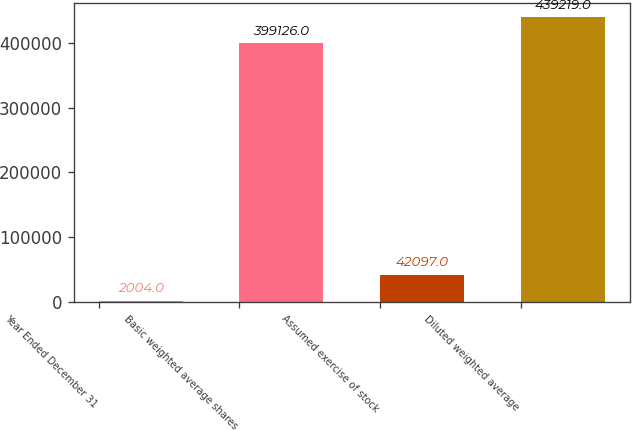Convert chart. <chart><loc_0><loc_0><loc_500><loc_500><bar_chart><fcel>Year Ended December 31<fcel>Basic weighted average shares<fcel>Assumed exercise of stock<fcel>Diluted weighted average<nl><fcel>2004<fcel>399126<fcel>42097<fcel>439219<nl></chart> 